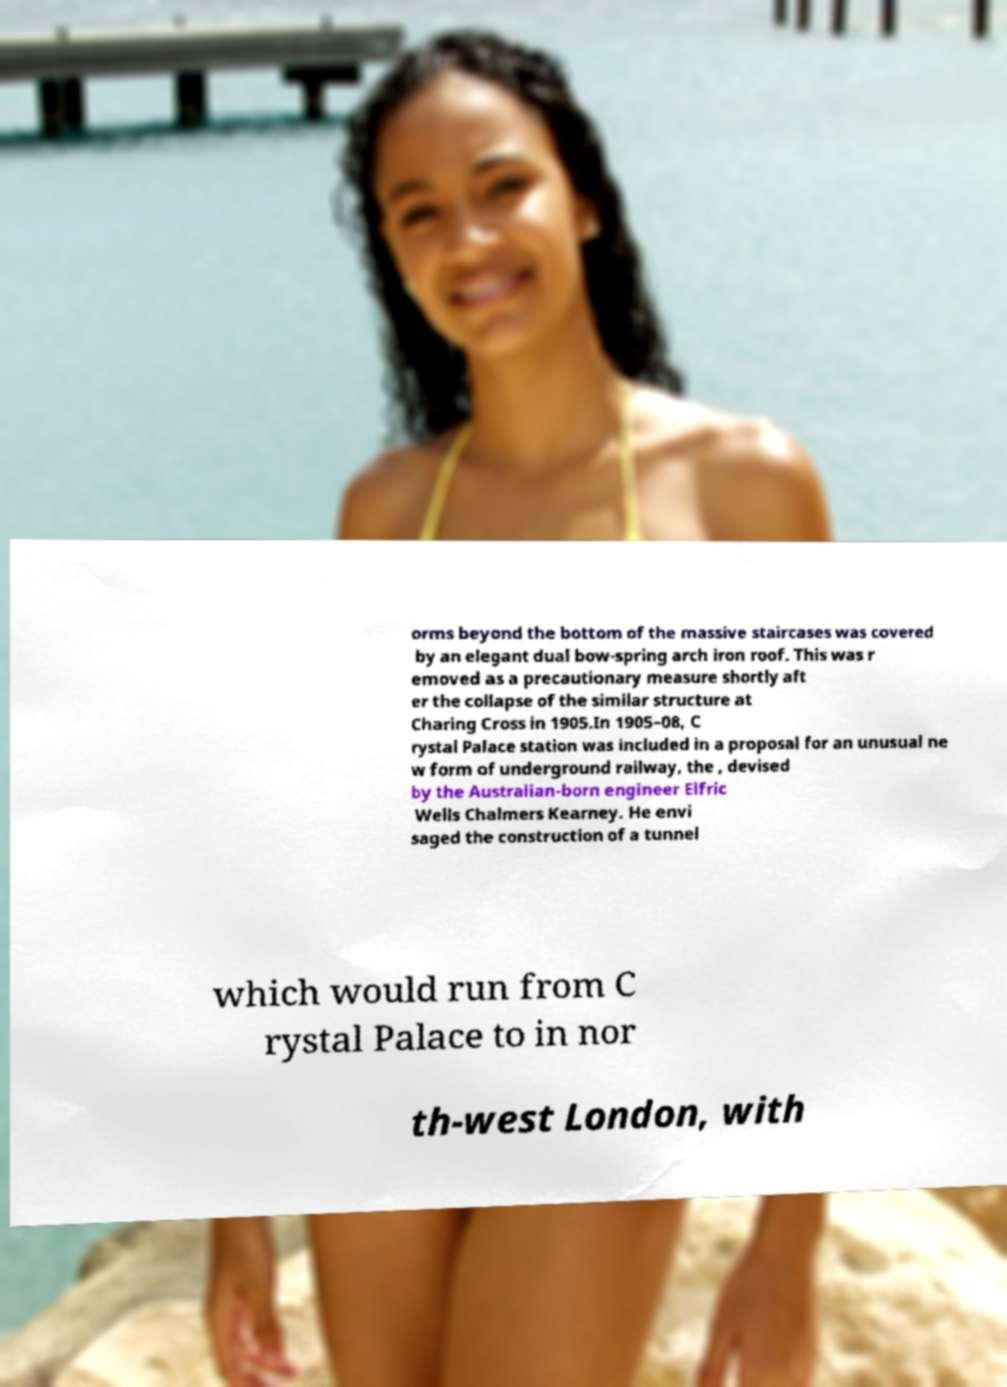Please read and relay the text visible in this image. What does it say? orms beyond the bottom of the massive staircases was covered by an elegant dual bow-spring arch iron roof. This was r emoved as a precautionary measure shortly aft er the collapse of the similar structure at Charing Cross in 1905.In 1905–08, C rystal Palace station was included in a proposal for an unusual ne w form of underground railway, the , devised by the Australian-born engineer Elfric Wells Chalmers Kearney. He envi saged the construction of a tunnel which would run from C rystal Palace to in nor th-west London, with 